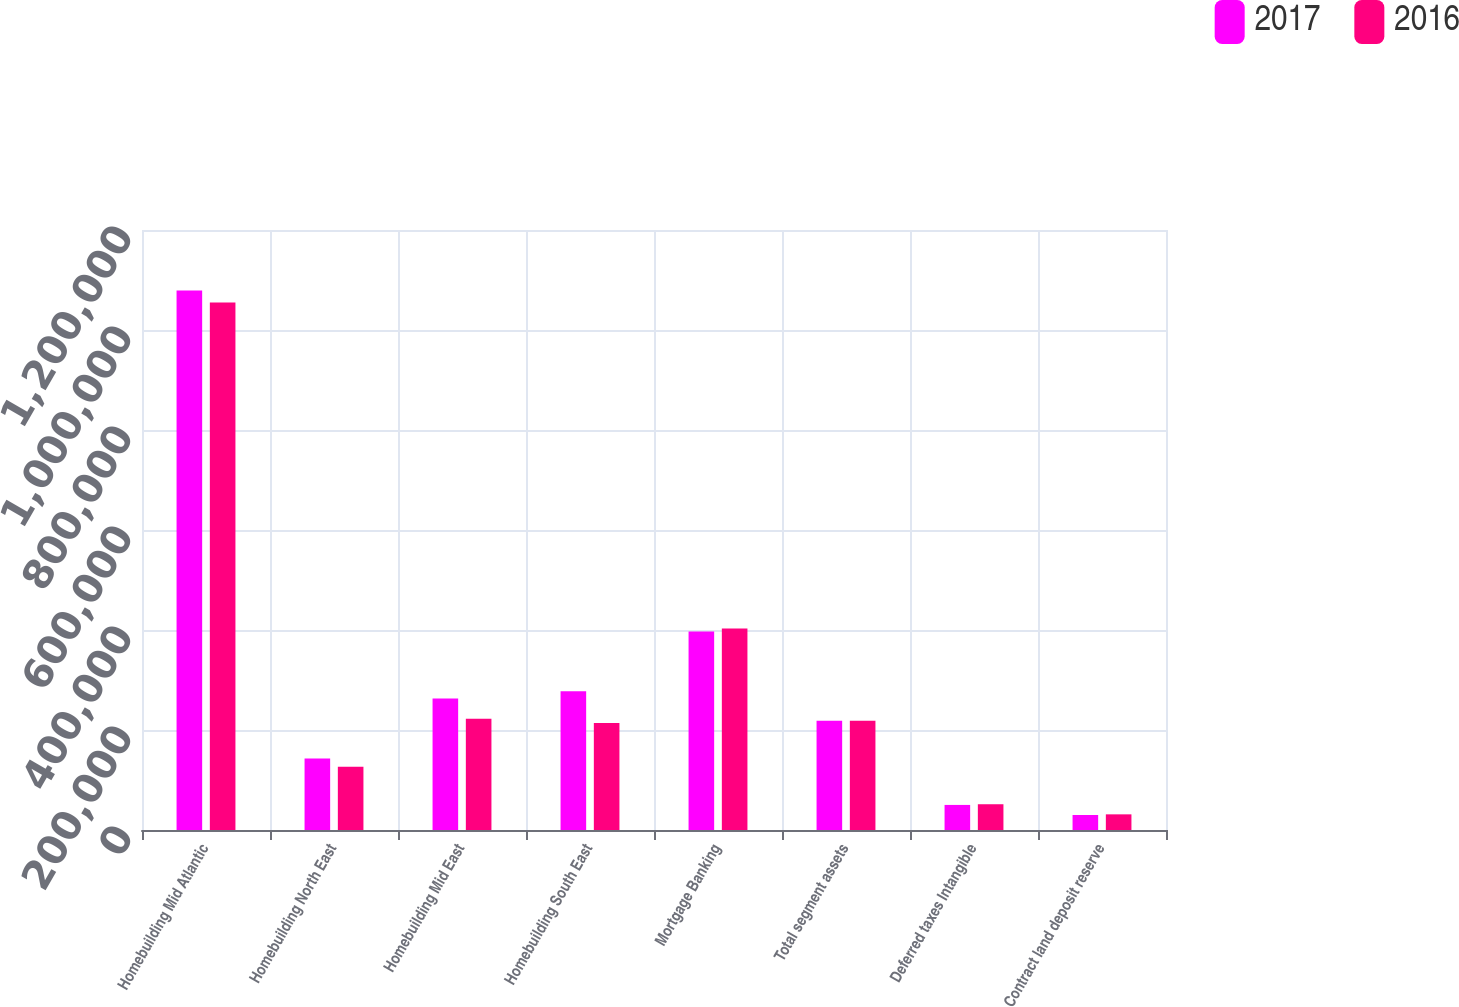Convert chart to OTSL. <chart><loc_0><loc_0><loc_500><loc_500><stacked_bar_chart><ecel><fcel>Homebuilding Mid Atlantic<fcel>Homebuilding North East<fcel>Homebuilding Mid East<fcel>Homebuilding South East<fcel>Mortgage Banking<fcel>Total segment assets<fcel>Deferred taxes Intangible<fcel>Contract land deposit reserve<nl><fcel>2017<fcel>1.07922e+06<fcel>143008<fcel>263019<fcel>277705<fcel>397052<fcel>218480<fcel>50144<fcel>29999<nl><fcel>2016<fcel>1.05478e+06<fcel>126720<fcel>222736<fcel>214225<fcel>403250<fcel>218480<fcel>51526<fcel>31306<nl></chart> 